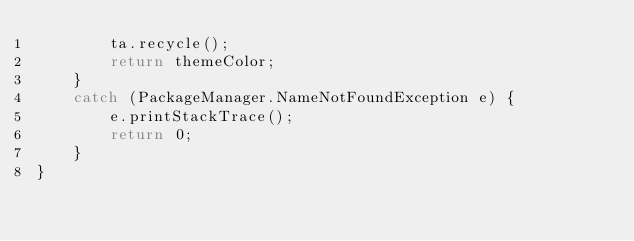Convert code to text. <code><loc_0><loc_0><loc_500><loc_500><_Ceylon_>        ta.recycle();
        return themeColor;
    }
    catch (PackageManager.NameNotFoundException e) {
        e.printStackTrace();
        return 0;
    }
}

</code> 